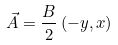<formula> <loc_0><loc_0><loc_500><loc_500>\vec { A } = \frac { B } { 2 } \left ( - y , x \right )</formula> 